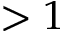<formula> <loc_0><loc_0><loc_500><loc_500>> 1</formula> 